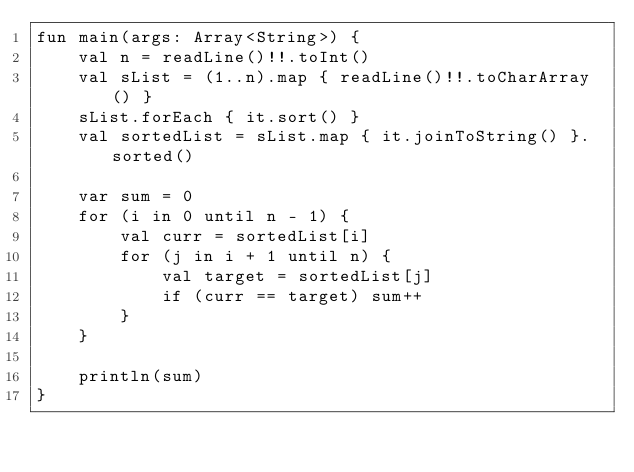Convert code to text. <code><loc_0><loc_0><loc_500><loc_500><_Kotlin_>fun main(args: Array<String>) {
    val n = readLine()!!.toInt()
    val sList = (1..n).map { readLine()!!.toCharArray() }
    sList.forEach { it.sort() }
    val sortedList = sList.map { it.joinToString() }.sorted()

    var sum = 0
    for (i in 0 until n - 1) {
        val curr = sortedList[i]
        for (j in i + 1 until n) {
            val target = sortedList[j]
            if (curr == target) sum++
        }
    }

    println(sum)
}
</code> 